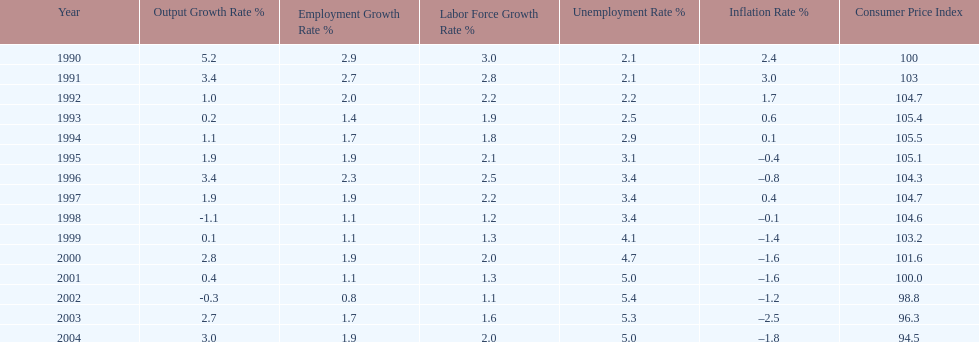What year saw the highest output growth rate in japan between the years 1990 and 2004? 1990. 